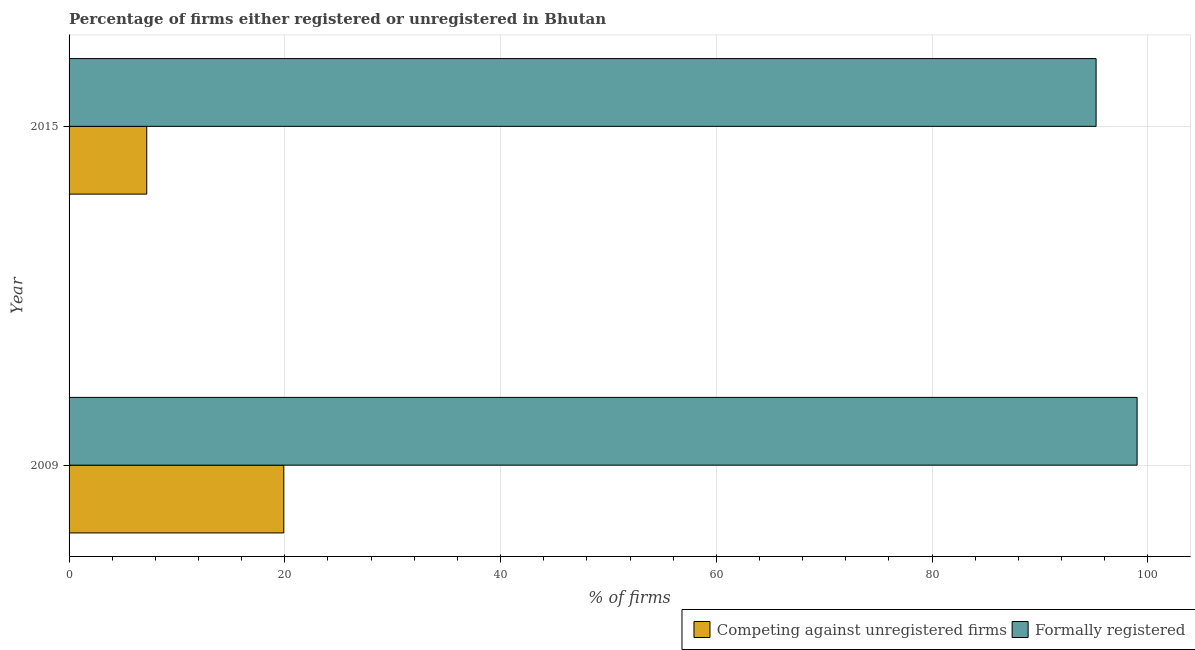In how many cases, is the number of bars for a given year not equal to the number of legend labels?
Provide a short and direct response. 0. What is the percentage of formally registered firms in 2015?
Offer a terse response. 95.2. Across all years, what is the minimum percentage of registered firms?
Offer a terse response. 7.2. In which year was the percentage of registered firms minimum?
Provide a short and direct response. 2015. What is the total percentage of formally registered firms in the graph?
Your answer should be very brief. 194.2. What is the difference between the percentage of registered firms in 2009 and that in 2015?
Offer a very short reply. 12.7. What is the difference between the percentage of registered firms in 2009 and the percentage of formally registered firms in 2015?
Offer a terse response. -75.3. What is the average percentage of formally registered firms per year?
Provide a succinct answer. 97.1. In the year 2009, what is the difference between the percentage of formally registered firms and percentage of registered firms?
Your response must be concise. 79.1. In how many years, is the percentage of registered firms greater than 64 %?
Provide a succinct answer. 0. What is the ratio of the percentage of registered firms in 2009 to that in 2015?
Ensure brevity in your answer.  2.76. What does the 2nd bar from the top in 2009 represents?
Offer a terse response. Competing against unregistered firms. What does the 2nd bar from the bottom in 2009 represents?
Your response must be concise. Formally registered. What is the difference between two consecutive major ticks on the X-axis?
Keep it short and to the point. 20. Does the graph contain any zero values?
Your answer should be very brief. No. Does the graph contain grids?
Provide a short and direct response. Yes. How many legend labels are there?
Offer a terse response. 2. How are the legend labels stacked?
Keep it short and to the point. Horizontal. What is the title of the graph?
Make the answer very short. Percentage of firms either registered or unregistered in Bhutan. What is the label or title of the X-axis?
Your answer should be compact. % of firms. What is the % of firms of Formally registered in 2015?
Offer a terse response. 95.2. Across all years, what is the minimum % of firms of Competing against unregistered firms?
Offer a terse response. 7.2. Across all years, what is the minimum % of firms in Formally registered?
Your answer should be very brief. 95.2. What is the total % of firms in Competing against unregistered firms in the graph?
Provide a short and direct response. 27.1. What is the total % of firms in Formally registered in the graph?
Your answer should be compact. 194.2. What is the difference between the % of firms in Formally registered in 2009 and that in 2015?
Make the answer very short. 3.8. What is the difference between the % of firms of Competing against unregistered firms in 2009 and the % of firms of Formally registered in 2015?
Ensure brevity in your answer.  -75.3. What is the average % of firms in Competing against unregistered firms per year?
Your response must be concise. 13.55. What is the average % of firms in Formally registered per year?
Offer a very short reply. 97.1. In the year 2009, what is the difference between the % of firms of Competing against unregistered firms and % of firms of Formally registered?
Keep it short and to the point. -79.1. In the year 2015, what is the difference between the % of firms in Competing against unregistered firms and % of firms in Formally registered?
Provide a short and direct response. -88. What is the ratio of the % of firms of Competing against unregistered firms in 2009 to that in 2015?
Offer a terse response. 2.76. What is the ratio of the % of firms of Formally registered in 2009 to that in 2015?
Your answer should be very brief. 1.04. What is the difference between the highest and the second highest % of firms of Competing against unregistered firms?
Give a very brief answer. 12.7. What is the difference between the highest and the lowest % of firms of Formally registered?
Offer a terse response. 3.8. 